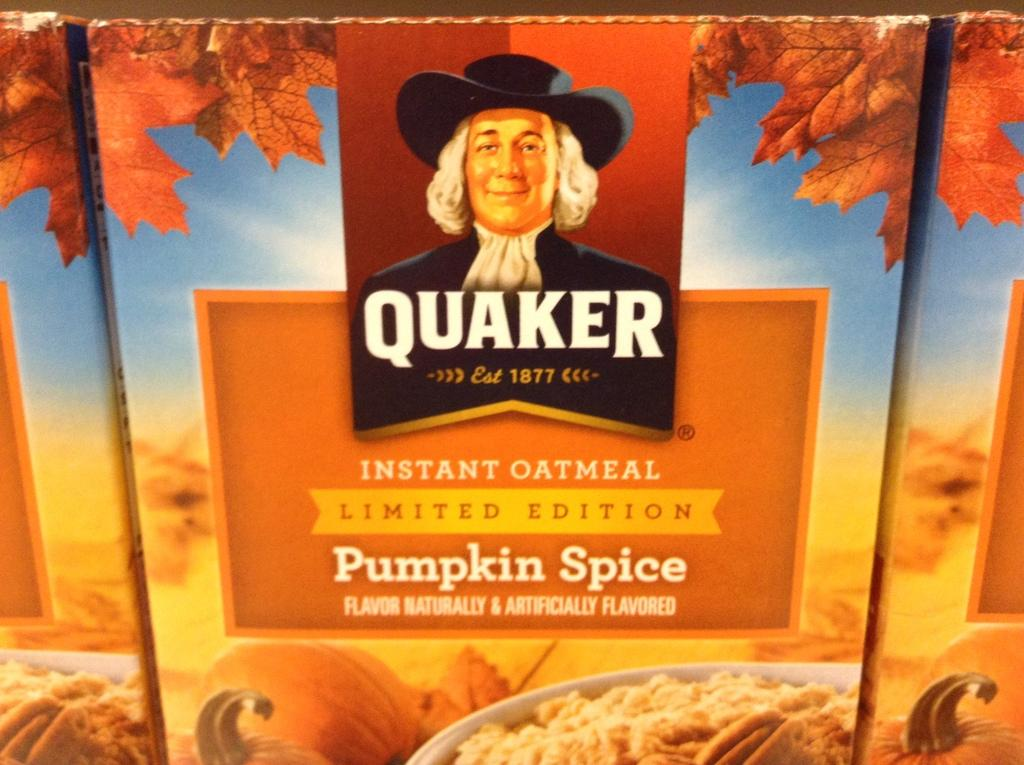What type of visual is the image? The image is a poster. Who or what is featured in the poster? There is a person depicted in the poster. What else can be seen in the poster besides the person? There are fruits, food items, leaves, and a name board in the poster. What type of bomb is being used by the person in the poster? There is no bomb present in the poster; it features a person, fruits, food items, leaves, and a name board. 